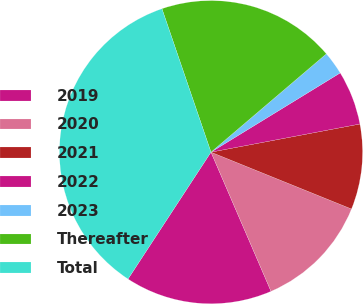Convert chart to OTSL. <chart><loc_0><loc_0><loc_500><loc_500><pie_chart><fcel>2019<fcel>2020<fcel>2021<fcel>2022<fcel>2023<fcel>Thereafter<fcel>Total<nl><fcel>15.7%<fcel>12.4%<fcel>9.09%<fcel>5.78%<fcel>2.48%<fcel>19.01%<fcel>35.54%<nl></chart> 